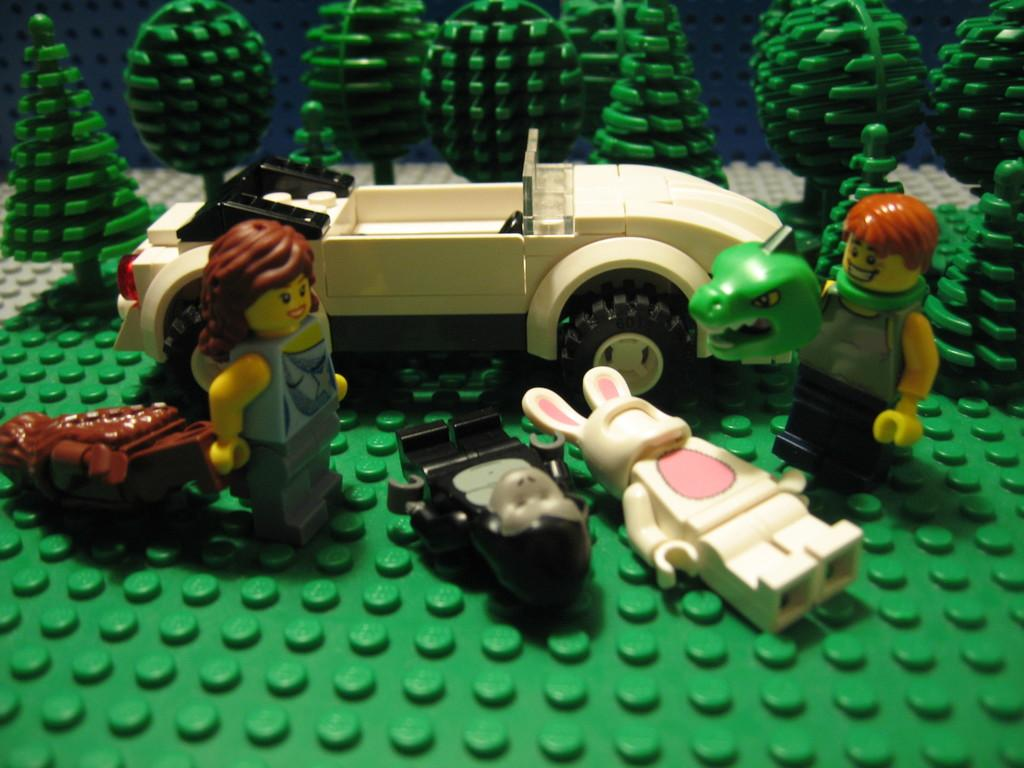What type of objects can be seen in the image? There are statues and a toy car in the image. What is the color of some objects in the image? There are green color objects in the image. How many levels are there in the image? There is no mention of levels in the image, as it features statues and a toy car. What type of knot can be seen in the image? There is no knot present in the image. 